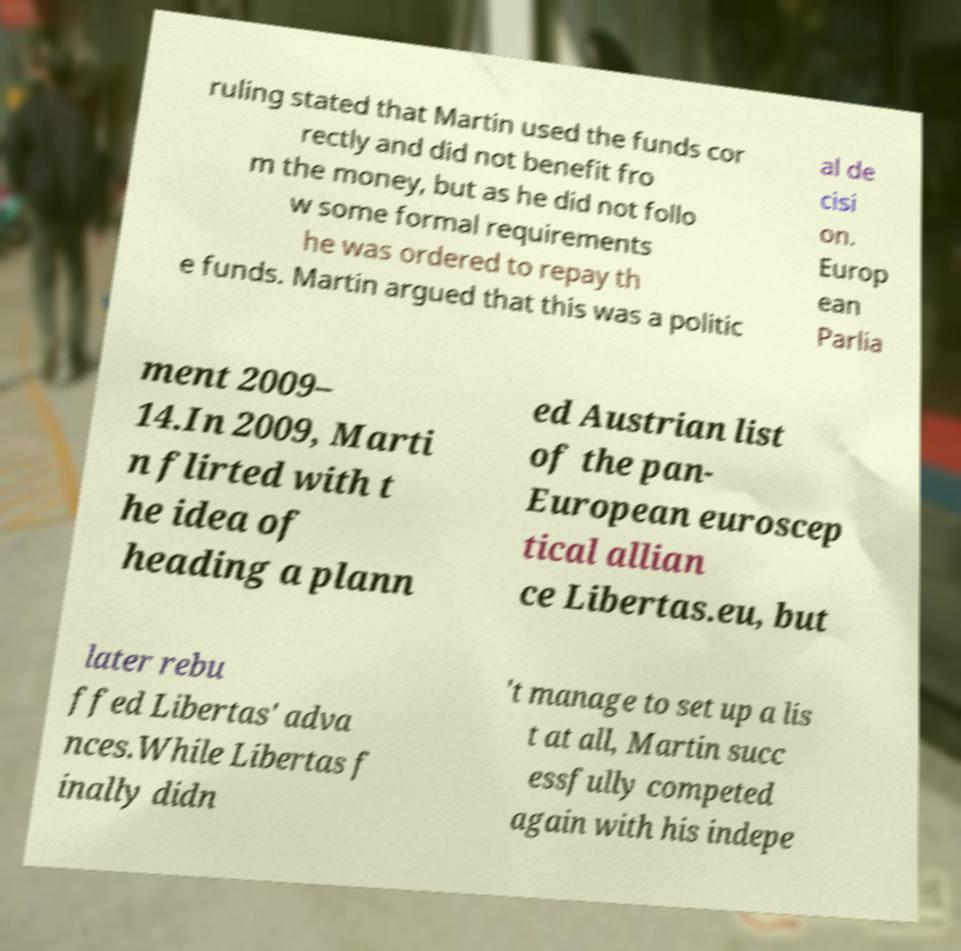Can you read and provide the text displayed in the image?This photo seems to have some interesting text. Can you extract and type it out for me? ruling stated that Martin used the funds cor rectly and did not benefit fro m the money, but as he did not follo w some formal requirements he was ordered to repay th e funds. Martin argued that this was a politic al de cisi on. Europ ean Parlia ment 2009– 14.In 2009, Marti n flirted with t he idea of heading a plann ed Austrian list of the pan- European euroscep tical allian ce Libertas.eu, but later rebu ffed Libertas' adva nces.While Libertas f inally didn 't manage to set up a lis t at all, Martin succ essfully competed again with his indepe 